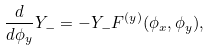<formula> <loc_0><loc_0><loc_500><loc_500>\frac { d } { d \phi _ { y } } Y _ { - } = - Y _ { - } F ^ { ( y ) } ( \phi _ { x } , \phi _ { y } ) ,</formula> 